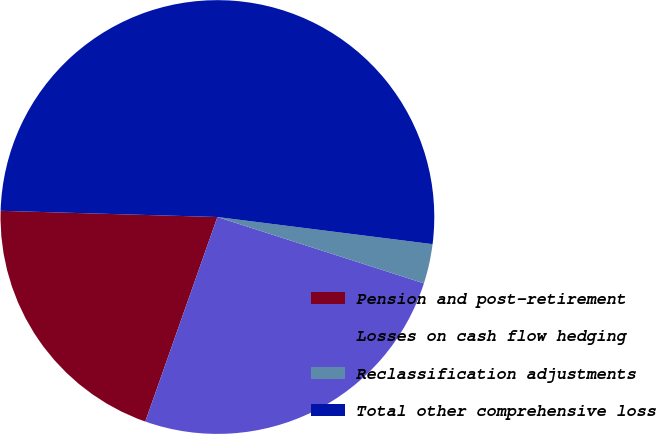Convert chart to OTSL. <chart><loc_0><loc_0><loc_500><loc_500><pie_chart><fcel>Pension and post-retirement<fcel>Losses on cash flow hedging<fcel>Reclassification adjustments<fcel>Total other comprehensive loss<nl><fcel>20.06%<fcel>25.45%<fcel>2.95%<fcel>51.54%<nl></chart> 